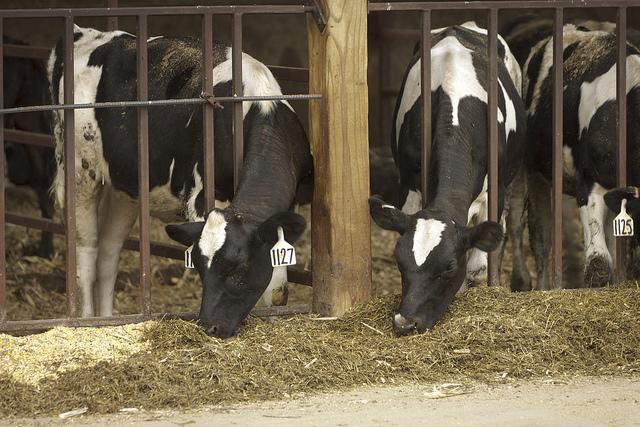Create a heartwarming short story involving one of these cows. Once upon a time, in a cozy and bustling barn, there was a gentle cow named Bella. Bella was known among the herd for her soft eyes and kind heart. She always made sure the younger calves had their fill of food before she started eating and often offered her neat spot under the soft, warm lights to those feeling a bit cold. One chilly winter night, a small calf named Daisy felt the harsh bite of the cold and started shivering. Noticing this, Bella nudged the little one closer and enveloped her with her warm body, providing comfort and warmth. Over time, Bella's nurturing nature was recognized by the farmers, and she soon became the trusted companion of all new calves, ensuring they felt safe and loved. Bella's nurturing spirit created a bond of trust and affection, which made her the heart of the barn. 